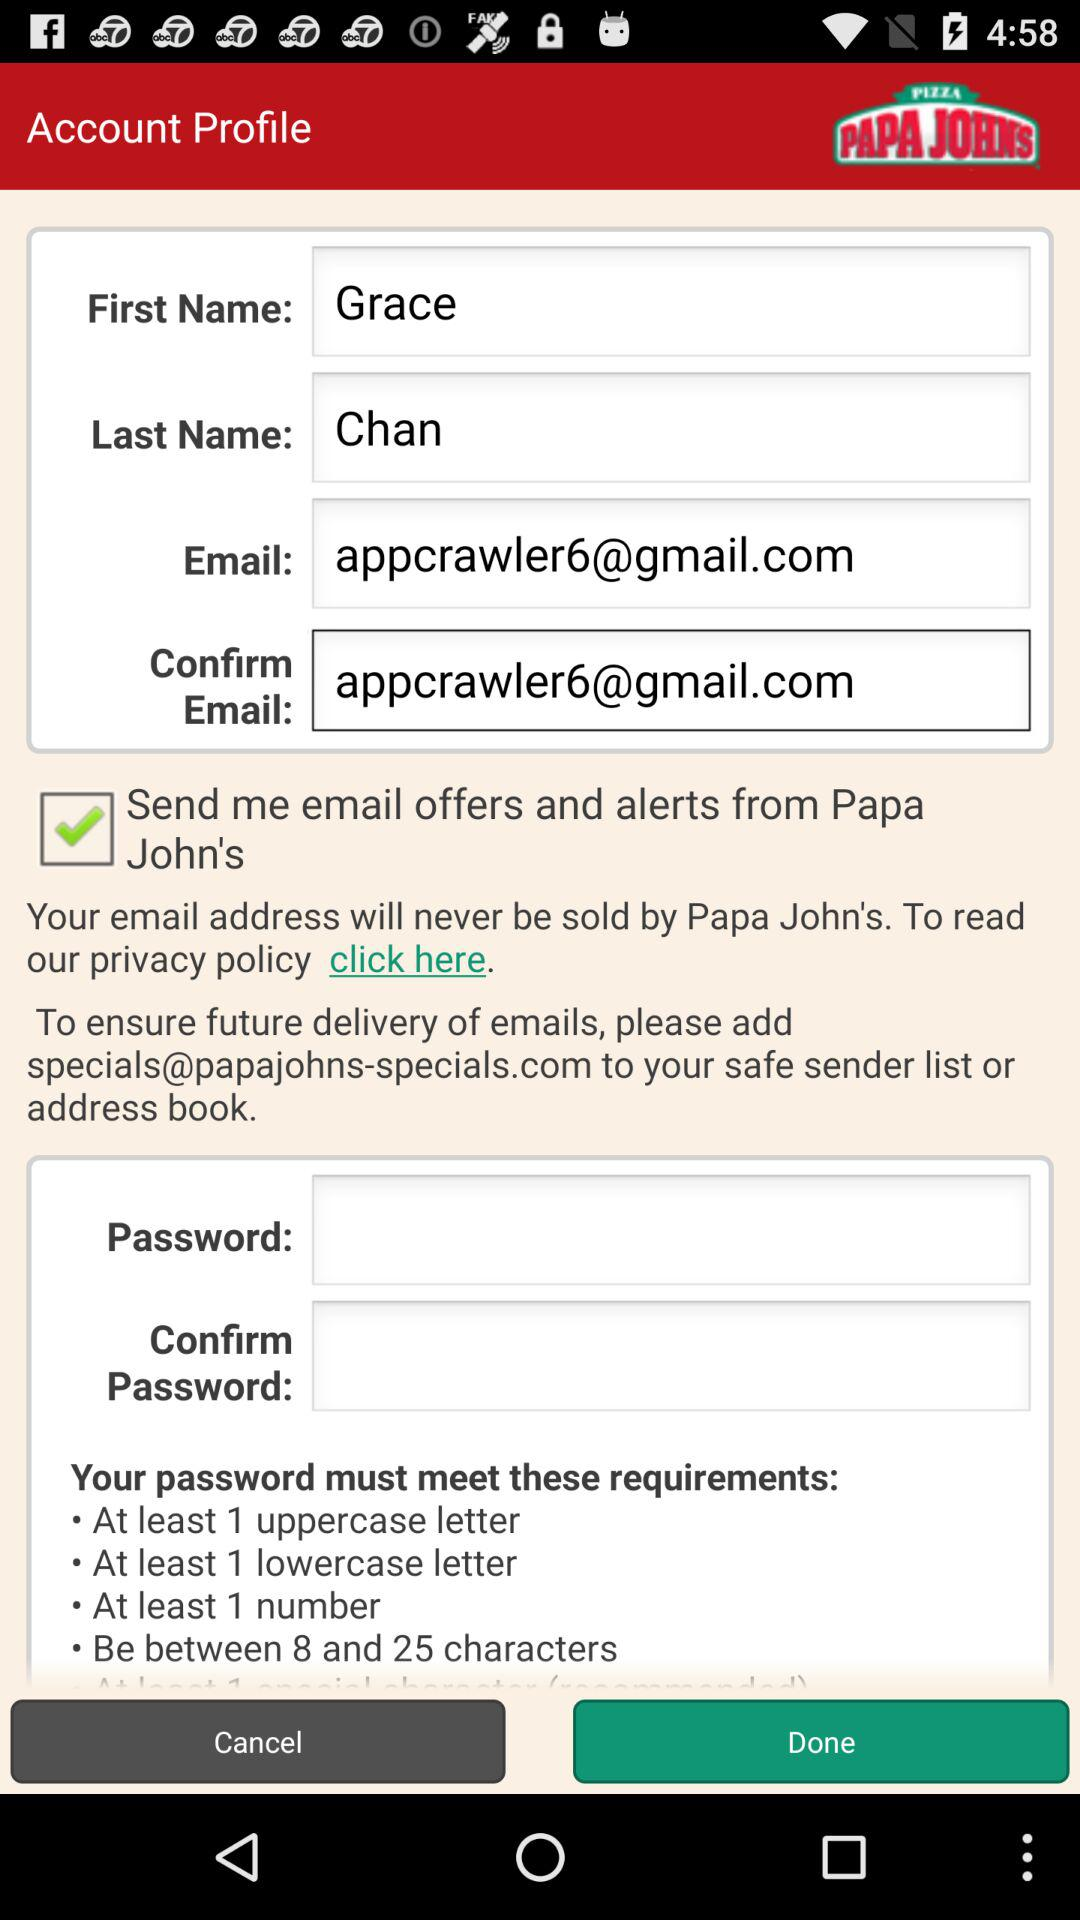What is the minimum number of uppercase letter required? The minimum number is 1. 